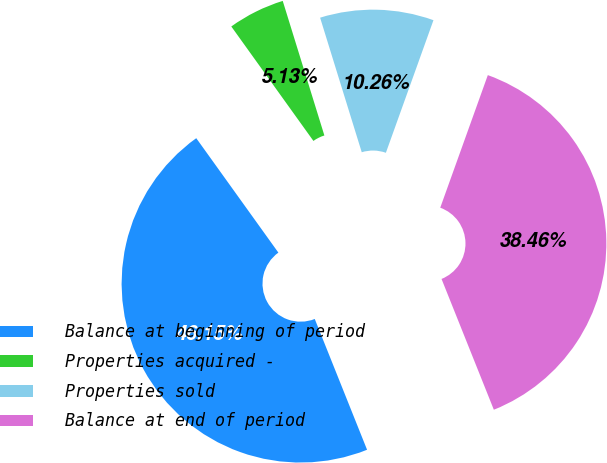Convert chart. <chart><loc_0><loc_0><loc_500><loc_500><pie_chart><fcel>Balance at beginning of period<fcel>Properties acquired -<fcel>Properties sold<fcel>Balance at end of period<nl><fcel>46.15%<fcel>5.13%<fcel>10.26%<fcel>38.46%<nl></chart> 